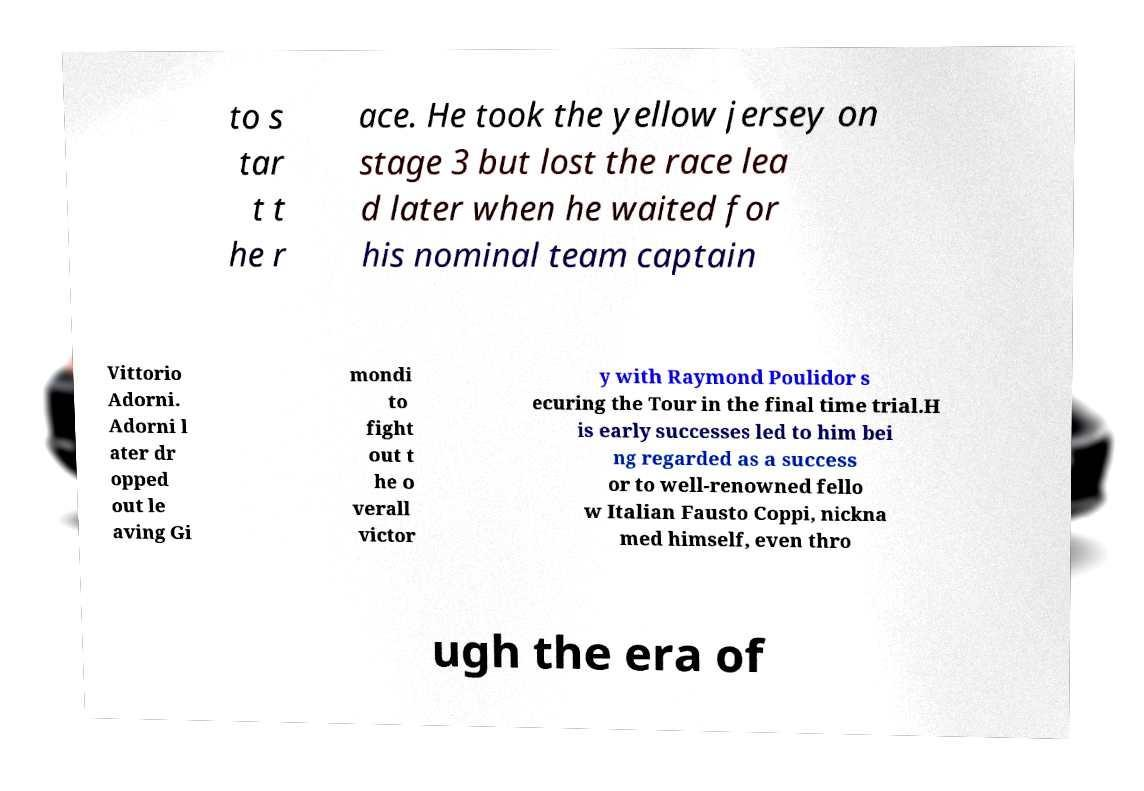Can you accurately transcribe the text from the provided image for me? to s tar t t he r ace. He took the yellow jersey on stage 3 but lost the race lea d later when he waited for his nominal team captain Vittorio Adorni. Adorni l ater dr opped out le aving Gi mondi to fight out t he o verall victor y with Raymond Poulidor s ecuring the Tour in the final time trial.H is early successes led to him bei ng regarded as a success or to well-renowned fello w Italian Fausto Coppi, nickna med himself, even thro ugh the era of 